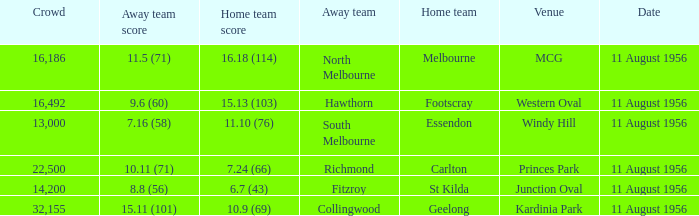What home team played at western oval? Footscray. 